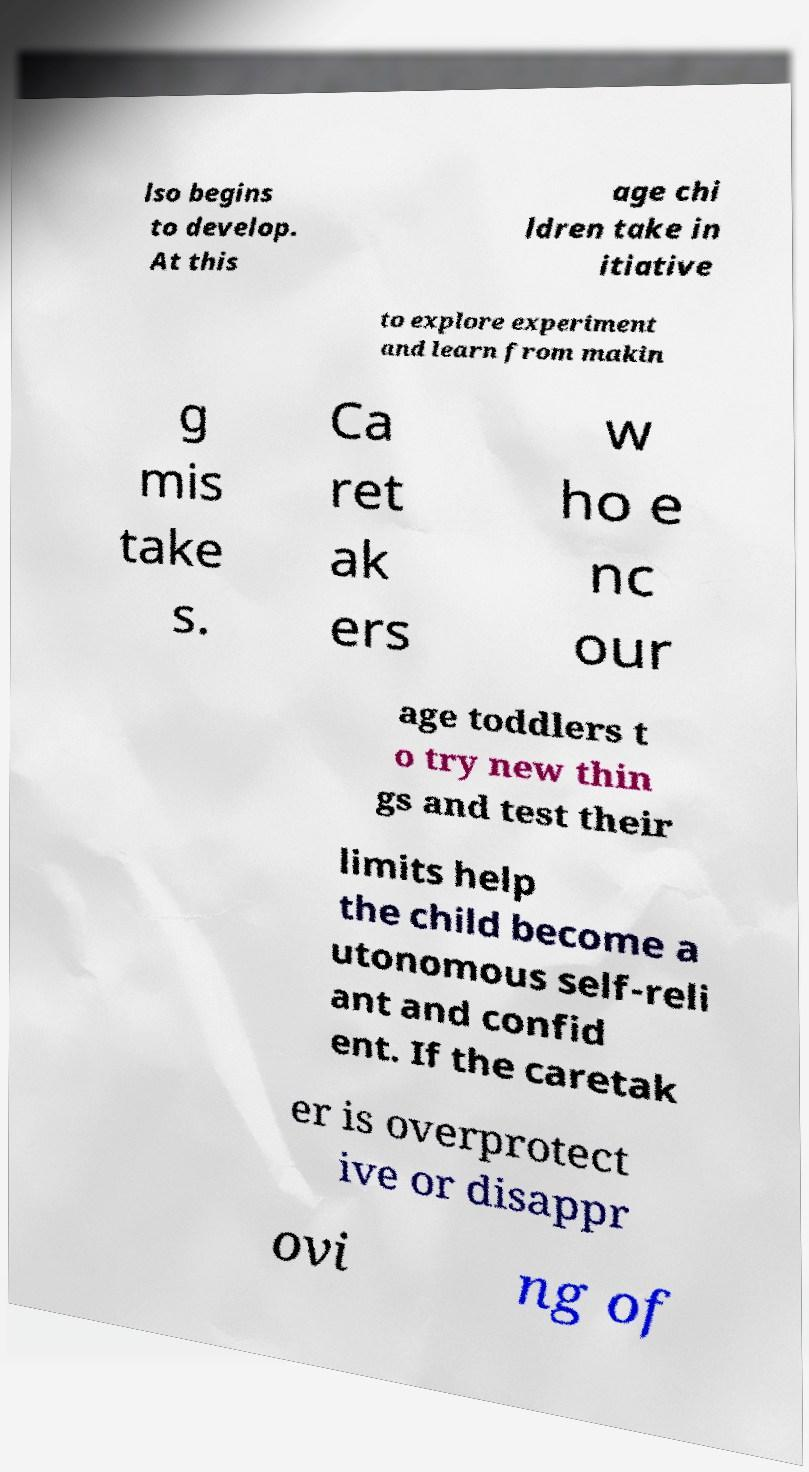What messages or text are displayed in this image? I need them in a readable, typed format. lso begins to develop. At this age chi ldren take in itiative to explore experiment and learn from makin g mis take s. Ca ret ak ers w ho e nc our age toddlers t o try new thin gs and test their limits help the child become a utonomous self-reli ant and confid ent. If the caretak er is overprotect ive or disappr ovi ng of 